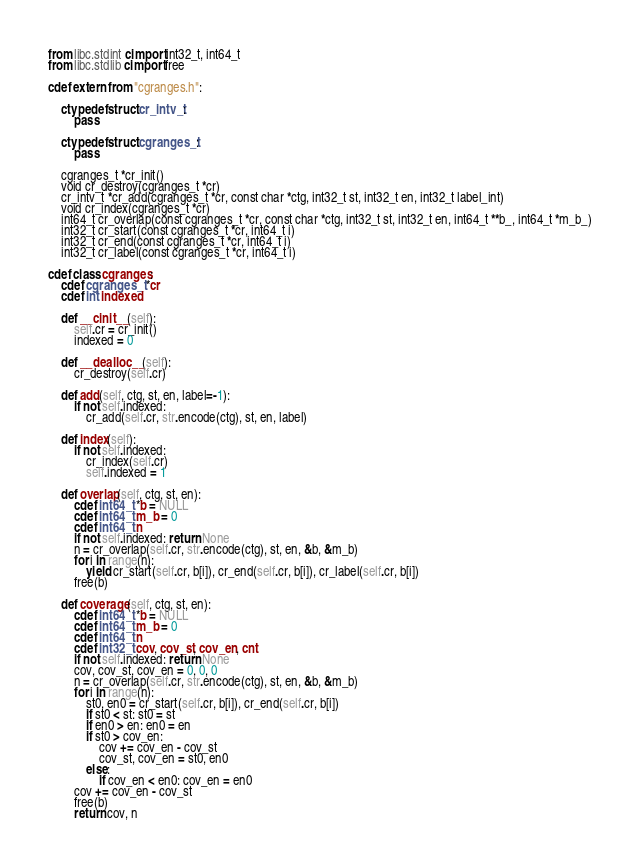Convert code to text. <code><loc_0><loc_0><loc_500><loc_500><_Cython_>from libc.stdint cimport int32_t, int64_t
from libc.stdlib cimport free

cdef extern from "cgranges.h":

	ctypedef struct cr_intv_t:
		pass

	ctypedef struct cgranges_t:
		pass

	cgranges_t *cr_init()
	void cr_destroy(cgranges_t *cr)
	cr_intv_t *cr_add(cgranges_t *cr, const char *ctg, int32_t st, int32_t en, int32_t label_int)
	void cr_index(cgranges_t *cr)
	int64_t cr_overlap(const cgranges_t *cr, const char *ctg, int32_t st, int32_t en, int64_t **b_, int64_t *m_b_)
	int32_t cr_start(const cgranges_t *cr, int64_t i)
	int32_t cr_end(const cgranges_t *cr, int64_t i)
	int32_t cr_label(const cgranges_t *cr, int64_t i)

cdef class cgranges:
	cdef cgranges_t *cr
	cdef int indexed

	def __cinit__(self):
		self.cr = cr_init()
		indexed = 0

	def __dealloc__(self):
		cr_destroy(self.cr)

	def add(self, ctg, st, en, label=-1):
		if not self.indexed:
			cr_add(self.cr, str.encode(ctg), st, en, label)

	def index(self):
		if not self.indexed:
			cr_index(self.cr)
			self.indexed = 1

	def overlap(self, ctg, st, en):
		cdef int64_t *b = NULL
		cdef int64_t m_b = 0
		cdef int64_t n
		if not self.indexed: return None
		n = cr_overlap(self.cr, str.encode(ctg), st, en, &b, &m_b)
		for i in range(n):
			yield cr_start(self.cr, b[i]), cr_end(self.cr, b[i]), cr_label(self.cr, b[i])
		free(b)

	def coverage(self, ctg, st, en):
		cdef int64_t *b = NULL
		cdef int64_t m_b = 0
		cdef int64_t n
		cdef int32_t cov, cov_st, cov_en, cnt
		if not self.indexed: return None
		cov, cov_st, cov_en = 0, 0, 0
		n = cr_overlap(self.cr, str.encode(ctg), st, en, &b, &m_b)
		for i in range(n):
			st0, en0 = cr_start(self.cr, b[i]), cr_end(self.cr, b[i])
			if st0 < st: st0 = st
			if en0 > en: en0 = en
			if st0 > cov_en:
				cov += cov_en - cov_st
				cov_st, cov_en = st0, en0
			else:
				if cov_en < en0: cov_en = en0
		cov += cov_en - cov_st
		free(b)
		return cov, n
</code> 